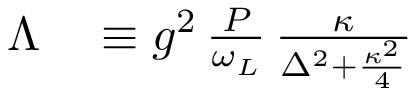<formula> <loc_0><loc_0><loc_500><loc_500>\begin{array} { r l } { \Lambda } & \equiv g ^ { 2 } \, \frac { P } { \omega _ { L } } \, \frac { \kappa } { \Delta ^ { 2 } + \frac { \kappa ^ { 2 } } { 4 } } } \end{array}</formula> 